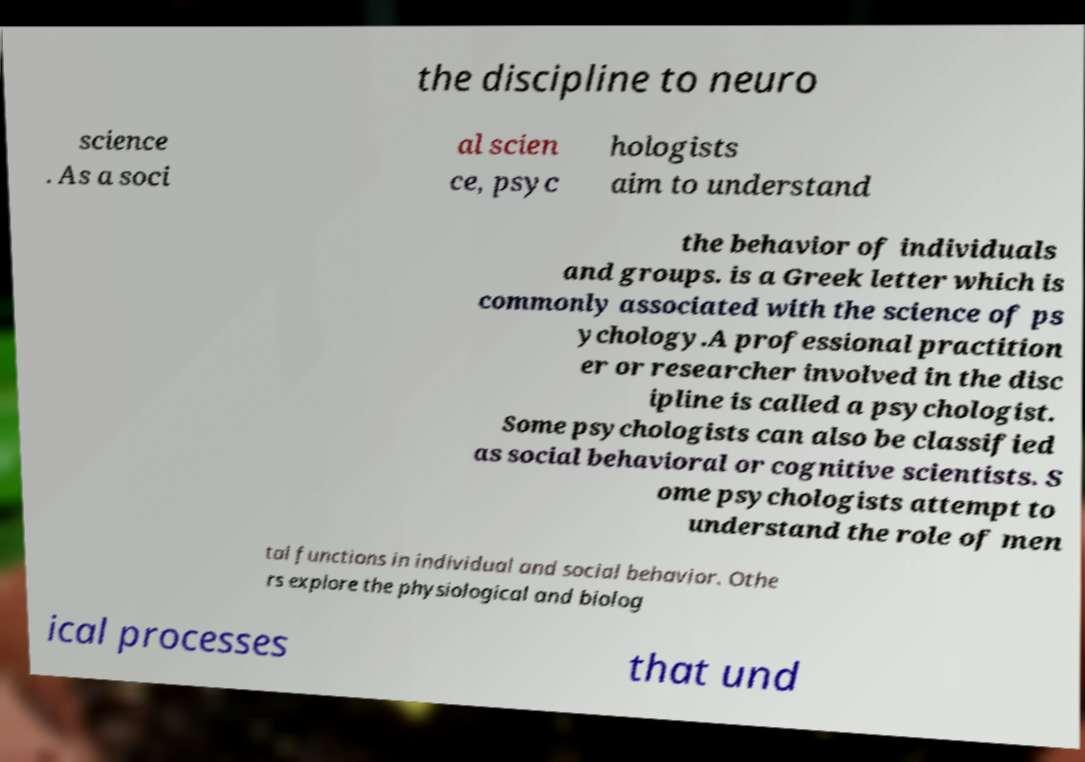There's text embedded in this image that I need extracted. Can you transcribe it verbatim? the discipline to neuro science . As a soci al scien ce, psyc hologists aim to understand the behavior of individuals and groups. is a Greek letter which is commonly associated with the science of ps ychology.A professional practition er or researcher involved in the disc ipline is called a psychologist. Some psychologists can also be classified as social behavioral or cognitive scientists. S ome psychologists attempt to understand the role of men tal functions in individual and social behavior. Othe rs explore the physiological and biolog ical processes that und 